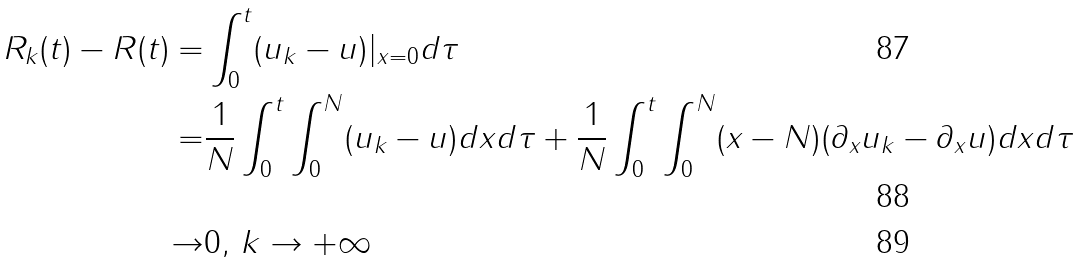Convert formula to latex. <formula><loc_0><loc_0><loc_500><loc_500>R _ { k } ( t ) - R ( t ) = & \int _ { 0 } ^ { t } ( u _ { k } - u ) | _ { x = 0 } d \tau \\ = & \frac { 1 } { N } \int _ { 0 } ^ { t } \int _ { 0 } ^ { N } ( u _ { k } - u ) d x d \tau + \frac { 1 } { N } \int _ { 0 } ^ { t } \int _ { 0 } ^ { N } ( x - N ) ( \partial _ { x } u _ { k } - \partial _ { x } u ) d x d \tau \\ \rightarrow & 0 , \, k \rightarrow + \infty</formula> 